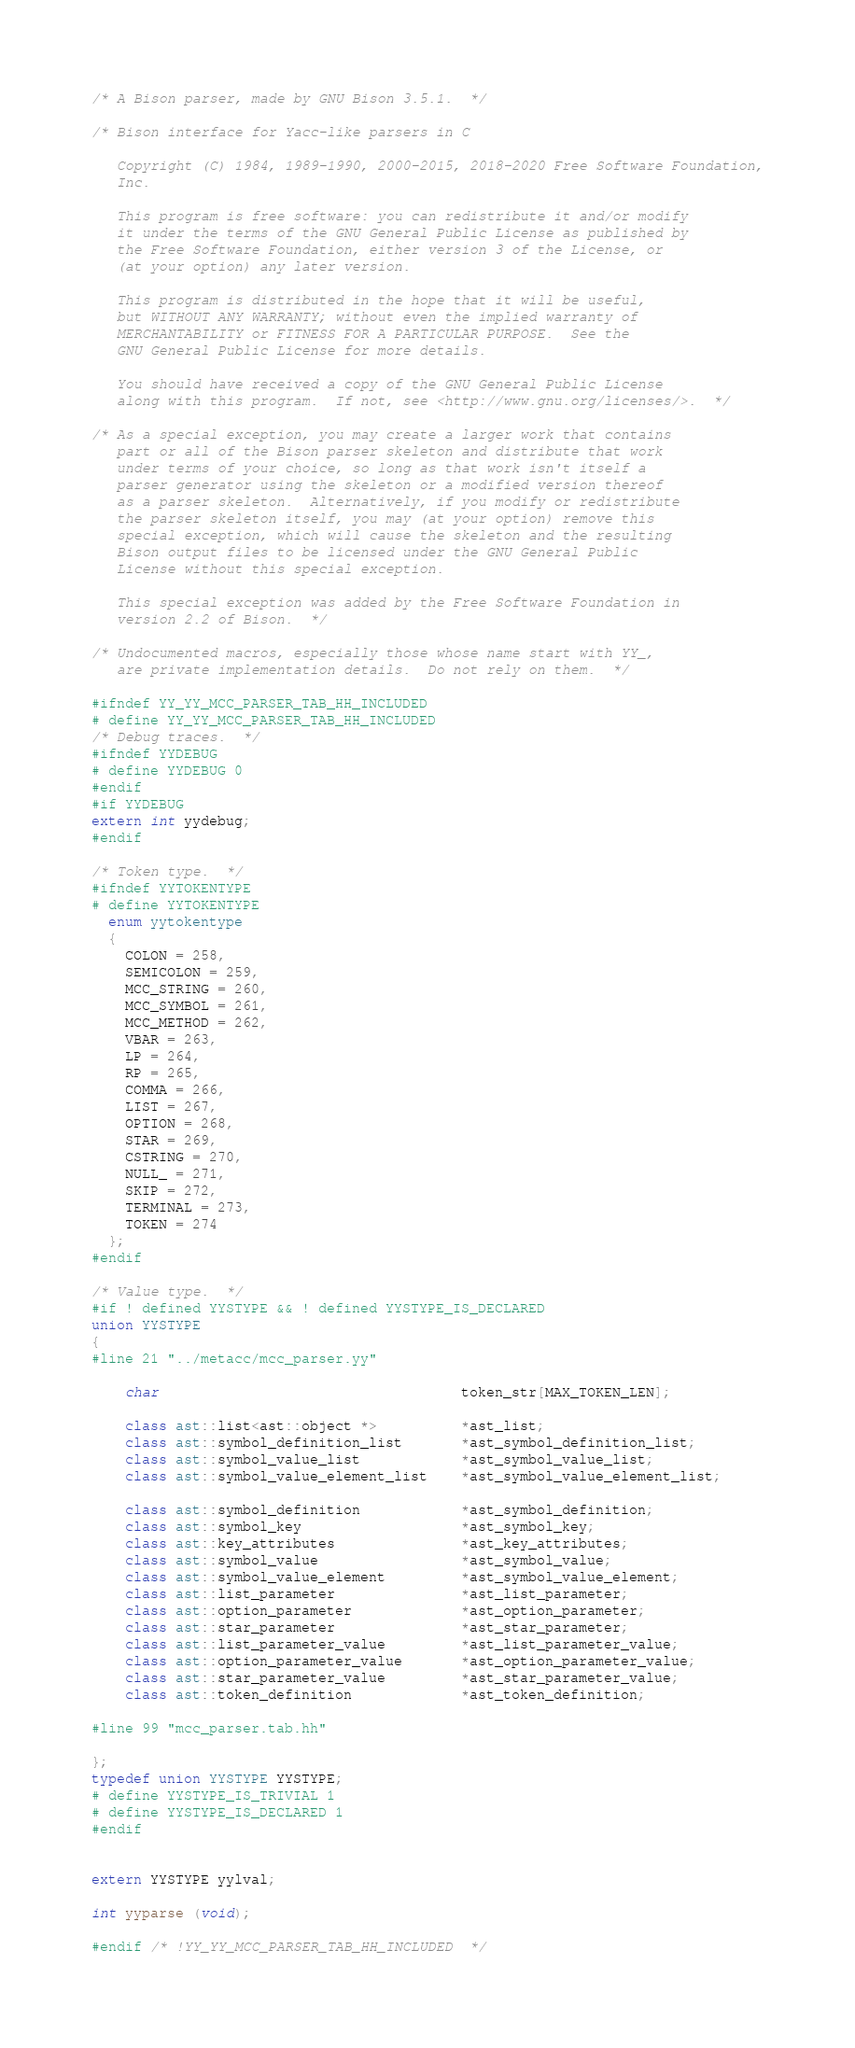Convert code to text. <code><loc_0><loc_0><loc_500><loc_500><_C++_>/* A Bison parser, made by GNU Bison 3.5.1.  */

/* Bison interface for Yacc-like parsers in C

   Copyright (C) 1984, 1989-1990, 2000-2015, 2018-2020 Free Software Foundation,
   Inc.

   This program is free software: you can redistribute it and/or modify
   it under the terms of the GNU General Public License as published by
   the Free Software Foundation, either version 3 of the License, or
   (at your option) any later version.

   This program is distributed in the hope that it will be useful,
   but WITHOUT ANY WARRANTY; without even the implied warranty of
   MERCHANTABILITY or FITNESS FOR A PARTICULAR PURPOSE.  See the
   GNU General Public License for more details.

   You should have received a copy of the GNU General Public License
   along with this program.  If not, see <http://www.gnu.org/licenses/>.  */

/* As a special exception, you may create a larger work that contains
   part or all of the Bison parser skeleton and distribute that work
   under terms of your choice, so long as that work isn't itself a
   parser generator using the skeleton or a modified version thereof
   as a parser skeleton.  Alternatively, if you modify or redistribute
   the parser skeleton itself, you may (at your option) remove this
   special exception, which will cause the skeleton and the resulting
   Bison output files to be licensed under the GNU General Public
   License without this special exception.

   This special exception was added by the Free Software Foundation in
   version 2.2 of Bison.  */

/* Undocumented macros, especially those whose name start with YY_,
   are private implementation details.  Do not rely on them.  */

#ifndef YY_YY_MCC_PARSER_TAB_HH_INCLUDED
# define YY_YY_MCC_PARSER_TAB_HH_INCLUDED
/* Debug traces.  */
#ifndef YYDEBUG
# define YYDEBUG 0
#endif
#if YYDEBUG
extern int yydebug;
#endif

/* Token type.  */
#ifndef YYTOKENTYPE
# define YYTOKENTYPE
  enum yytokentype
  {
    COLON = 258,
    SEMICOLON = 259,
    MCC_STRING = 260,
    MCC_SYMBOL = 261,
    MCC_METHOD = 262,
    VBAR = 263,
    LP = 264,
    RP = 265,
    COMMA = 266,
    LIST = 267,
    OPTION = 268,
    STAR = 269,
    CSTRING = 270,
    NULL_ = 271,
    SKIP = 272,
    TERMINAL = 273,
    TOKEN = 274
  };
#endif

/* Value type.  */
#if ! defined YYSTYPE && ! defined YYSTYPE_IS_DECLARED
union YYSTYPE
{
#line 21 "../metacc/mcc_parser.yy"

    char                                    token_str[MAX_TOKEN_LEN];

    class ast::list<ast::object *>          *ast_list;
    class ast::symbol_definition_list       *ast_symbol_definition_list;
    class ast::symbol_value_list            *ast_symbol_value_list;
    class ast::symbol_value_element_list    *ast_symbol_value_element_list;

    class ast::symbol_definition            *ast_symbol_definition;
    class ast::symbol_key                   *ast_symbol_key;
    class ast::key_attributes               *ast_key_attributes;
    class ast::symbol_value                 *ast_symbol_value;
    class ast::symbol_value_element         *ast_symbol_value_element;
    class ast::list_parameter               *ast_list_parameter;
    class ast::option_parameter             *ast_option_parameter;
    class ast::star_parameter               *ast_star_parameter;
    class ast::list_parameter_value         *ast_list_parameter_value;
    class ast::option_parameter_value       *ast_option_parameter_value;
    class ast::star_parameter_value         *ast_star_parameter_value;
    class ast::token_definition             *ast_token_definition;

#line 99 "mcc_parser.tab.hh"

};
typedef union YYSTYPE YYSTYPE;
# define YYSTYPE_IS_TRIVIAL 1
# define YYSTYPE_IS_DECLARED 1
#endif


extern YYSTYPE yylval;

int yyparse (void);

#endif /* !YY_YY_MCC_PARSER_TAB_HH_INCLUDED  */
</code> 